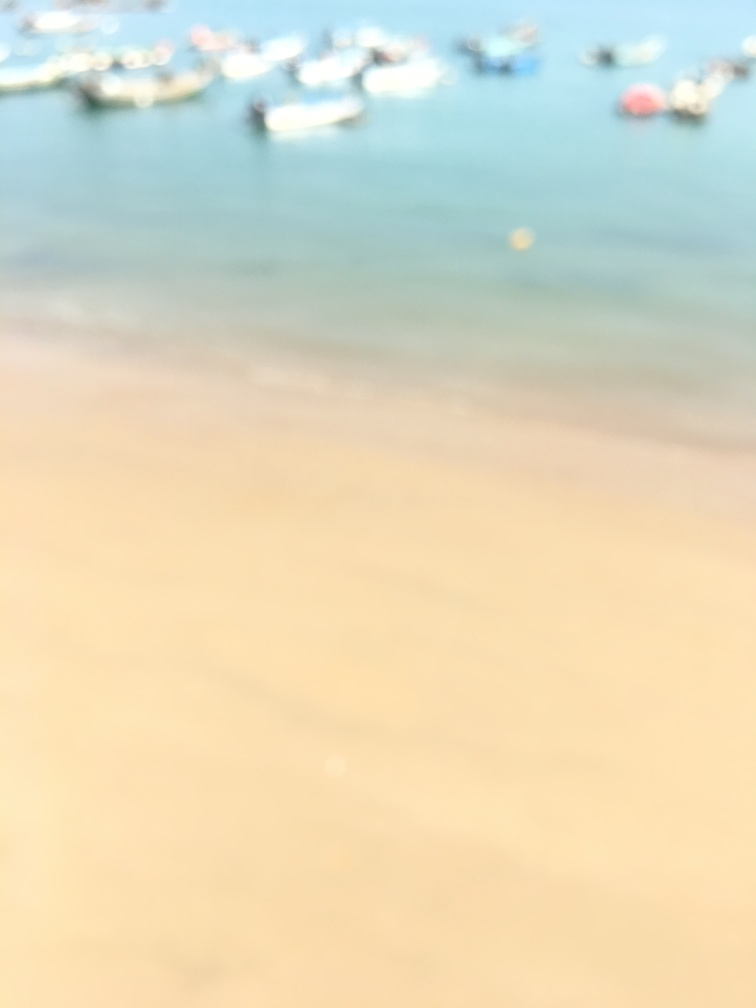This image seems out of focus. Could you attempt to describe what might be the cause of the blurriness? The blurriness in the image could be due to several factors, such as camera movement during exposure, incorrect focus settings on the camera, or a smudge on the lens. It could also be intentional to create an artistic effect or to obscure details. 